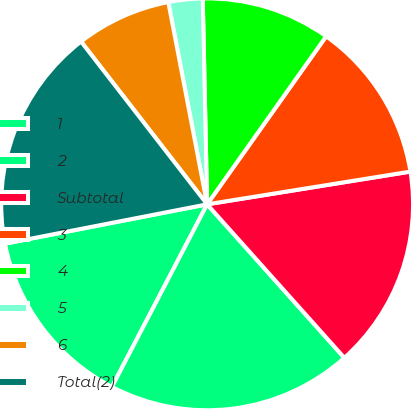Convert chart to OTSL. <chart><loc_0><loc_0><loc_500><loc_500><pie_chart><fcel>1<fcel>2<fcel>Subtotal<fcel>3<fcel>4<fcel>5<fcel>6<fcel>Total(2)<nl><fcel>14.29%<fcel>19.26%<fcel>15.93%<fcel>12.65%<fcel>10.15%<fcel>2.68%<fcel>7.47%<fcel>17.57%<nl></chart> 